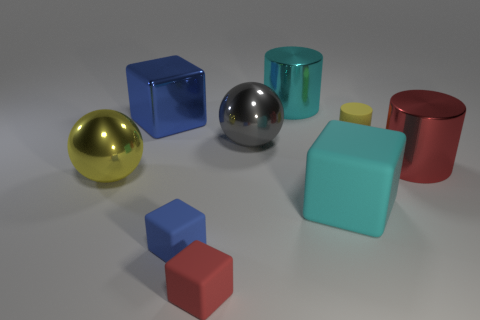There is a rubber thing on the left side of the red matte cube; what is its size?
Provide a short and direct response. Small. The big metallic object that is on the left side of the big cube that is behind the yellow rubber cylinder behind the small blue cube is what color?
Give a very brief answer. Yellow. The ball behind the metal thing that is in front of the big red cylinder is what color?
Make the answer very short. Gray. Are there more big shiny balls that are behind the big cyan cylinder than blue metallic cubes that are right of the small red rubber thing?
Give a very brief answer. No. Is the material of the large cube that is right of the large blue metallic object the same as the small thing that is behind the large cyan block?
Your answer should be very brief. Yes. There is a large blue metal cube; are there any red blocks behind it?
Your response must be concise. No. What number of yellow objects are blocks or rubber objects?
Provide a short and direct response. 1. Are the red block and the cylinder that is behind the small yellow rubber cylinder made of the same material?
Ensure brevity in your answer.  No. What is the size of the red rubber thing that is the same shape as the blue rubber thing?
Your answer should be compact. Small. What is the cyan cylinder made of?
Make the answer very short. Metal. 